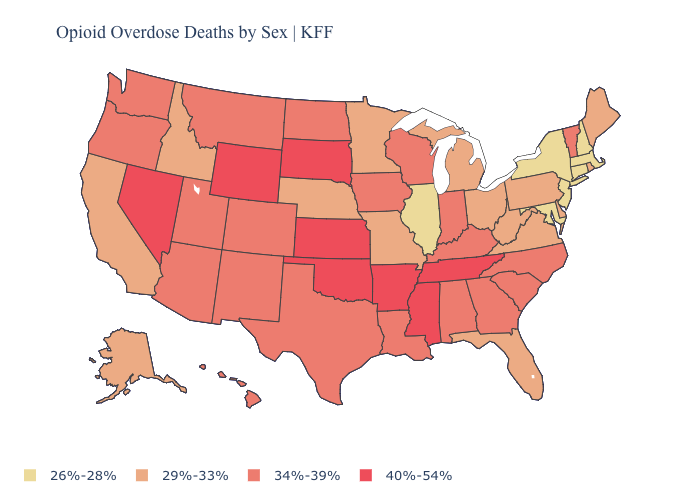Which states have the highest value in the USA?
Answer briefly. Arkansas, Kansas, Mississippi, Nevada, Oklahoma, South Dakota, Tennessee, Wyoming. Among the states that border Iowa , which have the lowest value?
Short answer required. Illinois. Does the map have missing data?
Quick response, please. No. What is the value of West Virginia?
Answer briefly. 29%-33%. Name the states that have a value in the range 26%-28%?
Concise answer only. Connecticut, Illinois, Maryland, Massachusetts, New Hampshire, New Jersey, New York. Name the states that have a value in the range 26%-28%?
Short answer required. Connecticut, Illinois, Maryland, Massachusetts, New Hampshire, New Jersey, New York. Name the states that have a value in the range 29%-33%?
Short answer required. Alaska, California, Delaware, Florida, Idaho, Maine, Michigan, Minnesota, Missouri, Nebraska, Ohio, Pennsylvania, Rhode Island, Virginia, West Virginia. Does Idaho have the same value as Nevada?
Answer briefly. No. What is the value of Wyoming?
Give a very brief answer. 40%-54%. Does Missouri have a lower value than Pennsylvania?
Concise answer only. No. Name the states that have a value in the range 29%-33%?
Concise answer only. Alaska, California, Delaware, Florida, Idaho, Maine, Michigan, Minnesota, Missouri, Nebraska, Ohio, Pennsylvania, Rhode Island, Virginia, West Virginia. What is the lowest value in the Northeast?
Quick response, please. 26%-28%. Name the states that have a value in the range 26%-28%?
Concise answer only. Connecticut, Illinois, Maryland, Massachusetts, New Hampshire, New Jersey, New York. Name the states that have a value in the range 34%-39%?
Concise answer only. Alabama, Arizona, Colorado, Georgia, Hawaii, Indiana, Iowa, Kentucky, Louisiana, Montana, New Mexico, North Carolina, North Dakota, Oregon, South Carolina, Texas, Utah, Vermont, Washington, Wisconsin. Among the states that border Nevada , does Oregon have the lowest value?
Write a very short answer. No. 